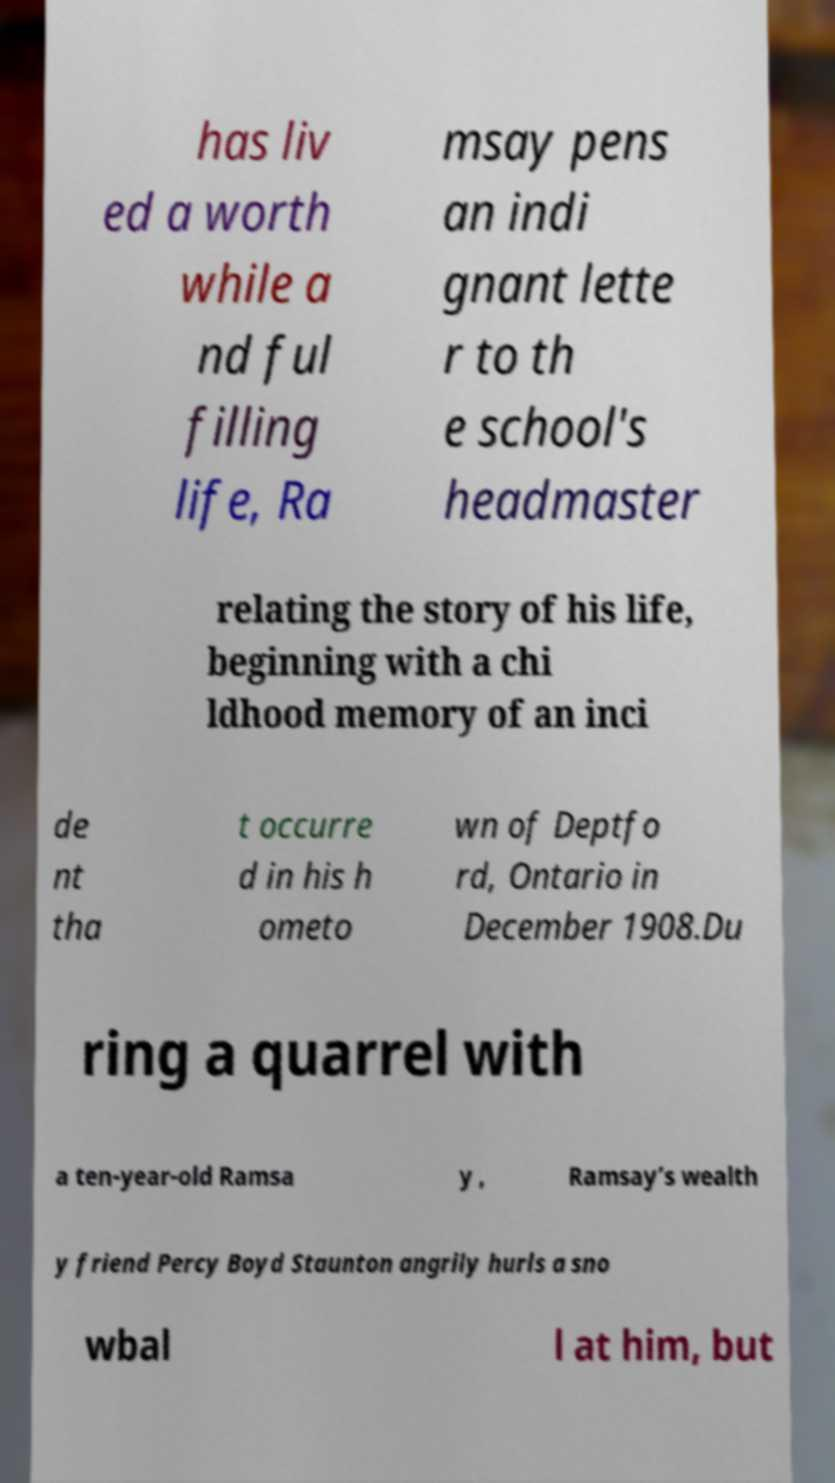For documentation purposes, I need the text within this image transcribed. Could you provide that? has liv ed a worth while a nd ful filling life, Ra msay pens an indi gnant lette r to th e school's headmaster relating the story of his life, beginning with a chi ldhood memory of an inci de nt tha t occurre d in his h ometo wn of Deptfo rd, Ontario in December 1908.Du ring a quarrel with a ten-year-old Ramsa y , Ramsay’s wealth y friend Percy Boyd Staunton angrily hurls a sno wbal l at him, but 